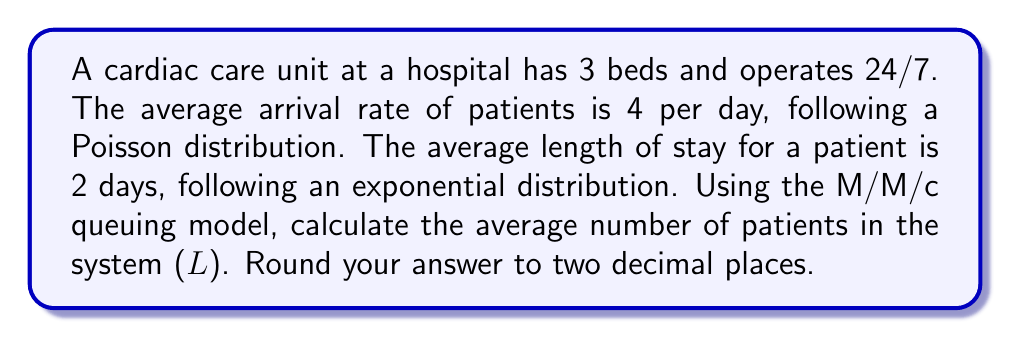Solve this math problem. To solve this problem, we'll use the M/M/c queuing model, where:
M: Arrival process is Markovian (Poisson)
M: Service times are Markovian (exponential)
c: Number of servers (beds)

Given:
- Arrival rate (λ) = 4 patients/day
- Service rate (μ) = 1/2 = 0.5 patients/day (since average stay is 2 days)
- Number of beds (c) = 3

Step 1: Calculate the utilization factor (ρ)
$$\rho = \frac{\lambda}{c\mu} = \frac{4}{3 \cdot 0.5} = \frac{8}{3} \approx 2.67$$

Step 2: Calculate $P_0$ (probability of an empty system)
$$P_0 = \left[\sum_{n=0}^{c-1}\frac{(c\rho)^n}{n!} + \frac{(c\rho)^c}{c!(1-\rho)}\right]^{-1}$$

$$P_0 = \left[1 + \frac{8}{1!} + \frac{8^2}{2!} + \frac{8^3}{3!(3-2.67)}\right]^{-1} \approx 0.0045$$

Step 3: Calculate $L_q$ (average number of patients in the queue)
$$L_q = \frac{P_0(c\rho)^c\rho}{c!(1-\rho)^2} \approx 21.33$$

Step 4: Calculate L (average number of patients in the system)
$$L = L_q + c\rho = 21.33 + 3 \cdot 2.67 = 29.34$$

Rounding to two decimal places: L ≈ 29.34
Answer: 29.34 